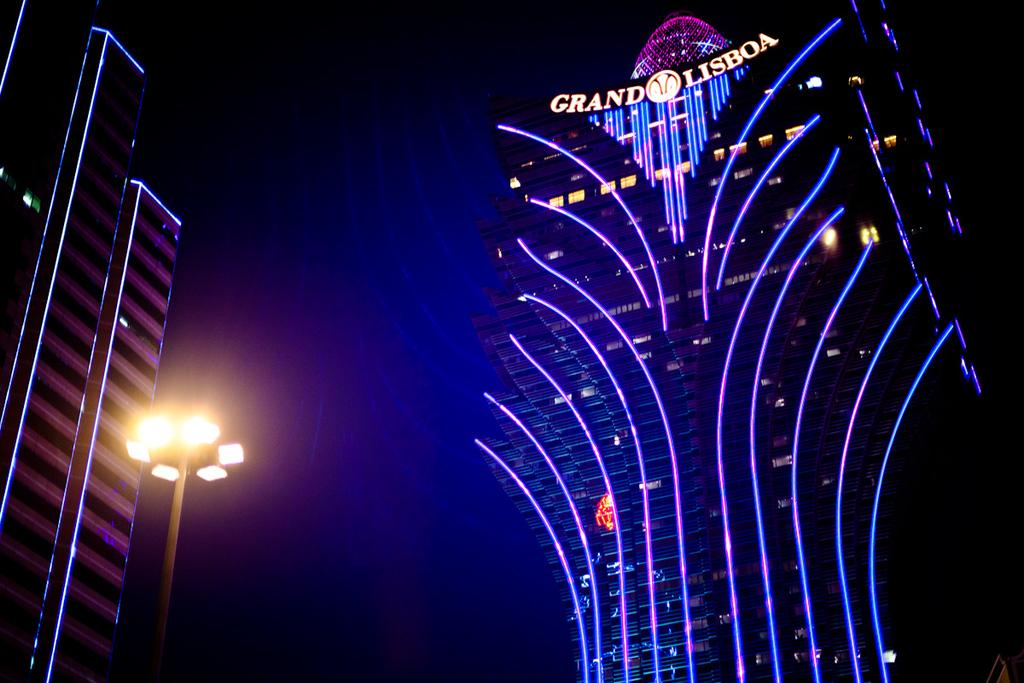What type of structures are visible in the image? There are buildings with lights in the image. Can you describe the lighting setup in the image? There is a focus light connected to a pole in the image. What is the overall appearance of the background in the image? The background of the image is dark. What type of sand can be seen in the image? There is no sand present in the image. How many pipes are visible in the image? There are no pipes visible in the image. 